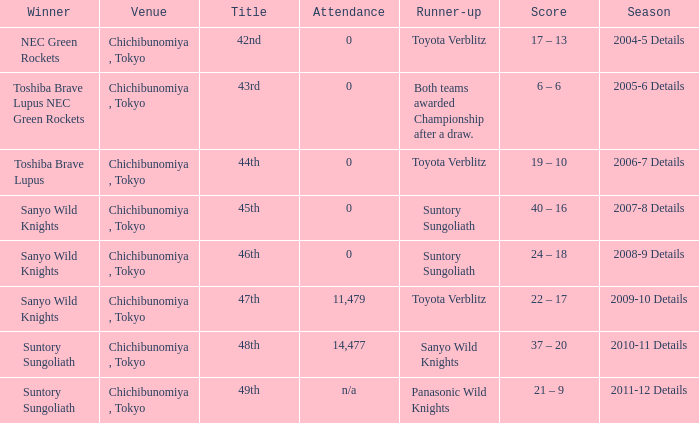What is the Attendance number for the title of 44th? 0.0. 